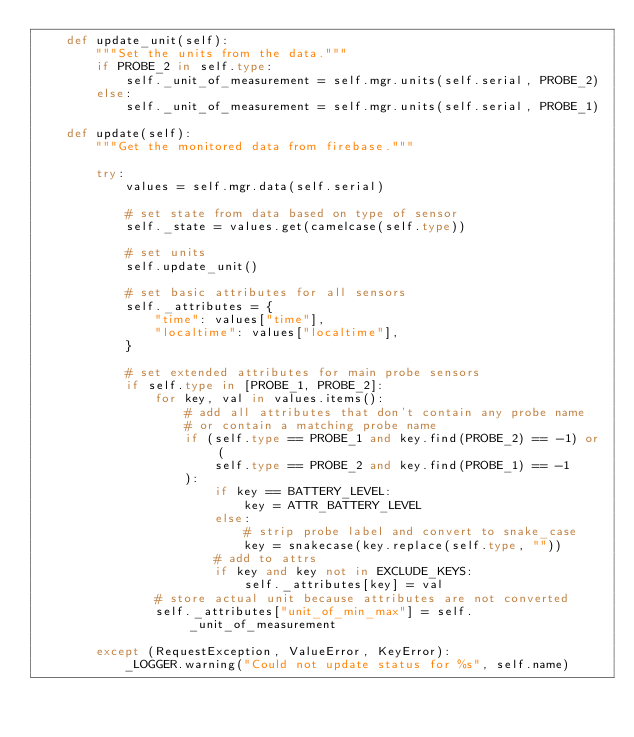<code> <loc_0><loc_0><loc_500><loc_500><_Python_>    def update_unit(self):
        """Set the units from the data."""
        if PROBE_2 in self.type:
            self._unit_of_measurement = self.mgr.units(self.serial, PROBE_2)
        else:
            self._unit_of_measurement = self.mgr.units(self.serial, PROBE_1)

    def update(self):
        """Get the monitored data from firebase."""

        try:
            values = self.mgr.data(self.serial)

            # set state from data based on type of sensor
            self._state = values.get(camelcase(self.type))

            # set units
            self.update_unit()

            # set basic attributes for all sensors
            self._attributes = {
                "time": values["time"],
                "localtime": values["localtime"],
            }

            # set extended attributes for main probe sensors
            if self.type in [PROBE_1, PROBE_2]:
                for key, val in values.items():
                    # add all attributes that don't contain any probe name
                    # or contain a matching probe name
                    if (self.type == PROBE_1 and key.find(PROBE_2) == -1) or (
                        self.type == PROBE_2 and key.find(PROBE_1) == -1
                    ):
                        if key == BATTERY_LEVEL:
                            key = ATTR_BATTERY_LEVEL
                        else:
                            # strip probe label and convert to snake_case
                            key = snakecase(key.replace(self.type, ""))
                        # add to attrs
                        if key and key not in EXCLUDE_KEYS:
                            self._attributes[key] = val
                # store actual unit because attributes are not converted
                self._attributes["unit_of_min_max"] = self._unit_of_measurement

        except (RequestException, ValueError, KeyError):
            _LOGGER.warning("Could not update status for %s", self.name)
</code> 